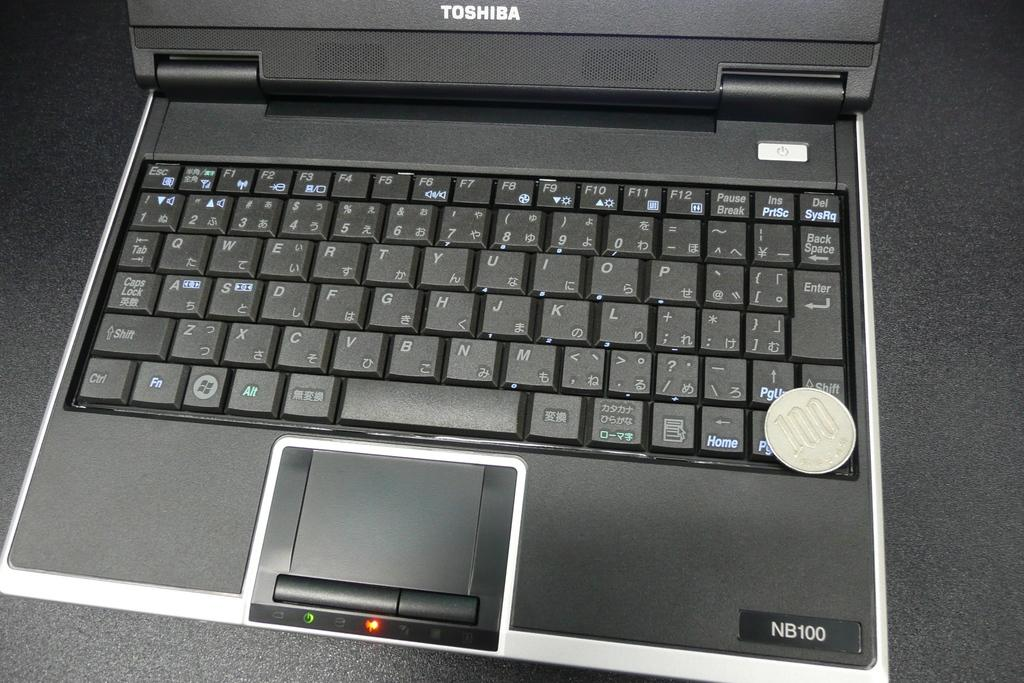<image>
Render a clear and concise summary of the photo. a computer that says toshiba as the brand name on it 